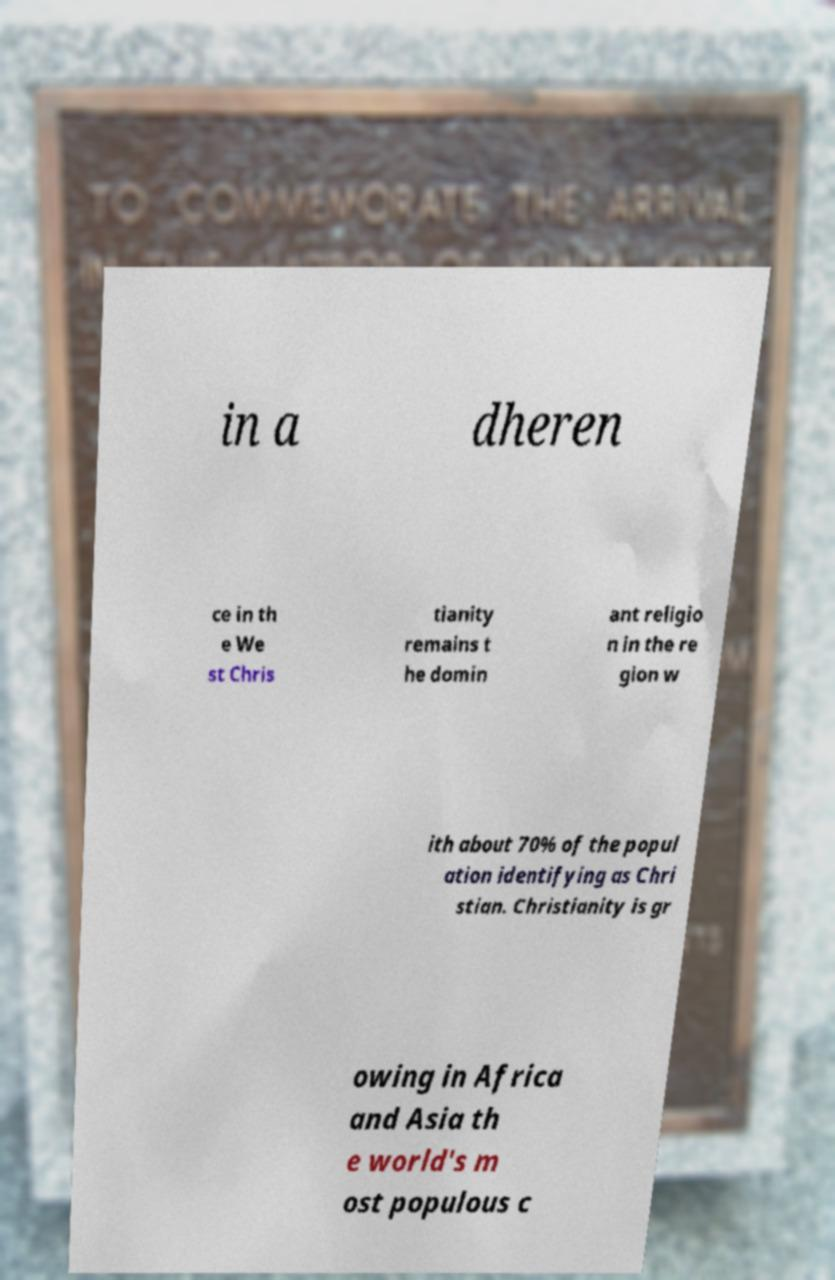Can you read and provide the text displayed in the image?This photo seems to have some interesting text. Can you extract and type it out for me? in a dheren ce in th e We st Chris tianity remains t he domin ant religio n in the re gion w ith about 70% of the popul ation identifying as Chri stian. Christianity is gr owing in Africa and Asia th e world's m ost populous c 